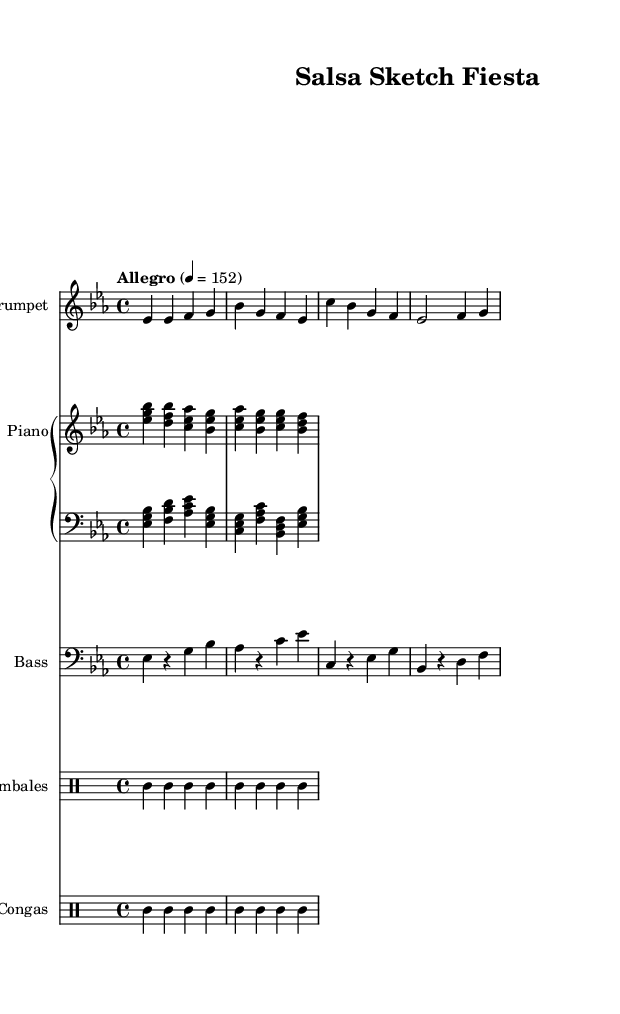What is the key signature of this music? The key signature indicates that the music is in E flat major, which has three flat symbols: B flat, E flat, and A flat. You can identify it by looking at the beginning of the staff where the flat symbols are displayed.
Answer: E flat major What is the time signature of this piece? The time signature is shown as 4/4, meaning there are four beats per measure and the quarter note gets one beat. You can find this indicated at the beginning of the score.
Answer: 4/4 What is the tempo marking for this composition? The tempo marking is indicated in text at the beginning of the score, specifying the speed of the piece. In this case, it shows "Allegro" along with a metronome mark of 152 beats per minute.
Answer: Allegro, 152 Who is the instrument playing the melody? The melody is primarily played by the trumpet, as indicated by the instrument name written at the beginning of the trumpet staff in the score.
Answer: Trumpet How many different rhythmic instruments are included in the arrangement? The arrangement includes two types of rhythmic instruments: timbales and congas, which are specified in their respective sections of the score. To determine this, one can simply count the distinct drum parts labeled in the score.
Answer: Two What type of chords are primarily used in the piano right hand? The piano right hand part consists of triads, where each grouping of notes forms a three-note chord, identifiable by looking at the note groupings on the staff.
Answer: Triads What is the predominant style of the music? The style of the music is identified as Salsa, a genre rooted in Latin music. This can be inferred from the instrumentation and rhythmic feel suitable for dance.
Answer: Salsa 